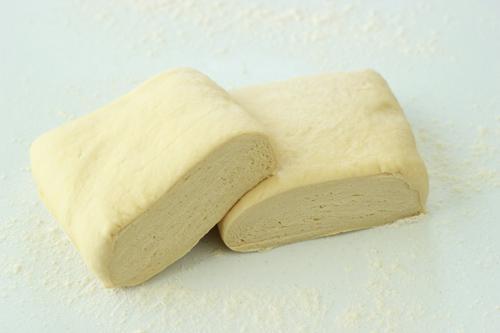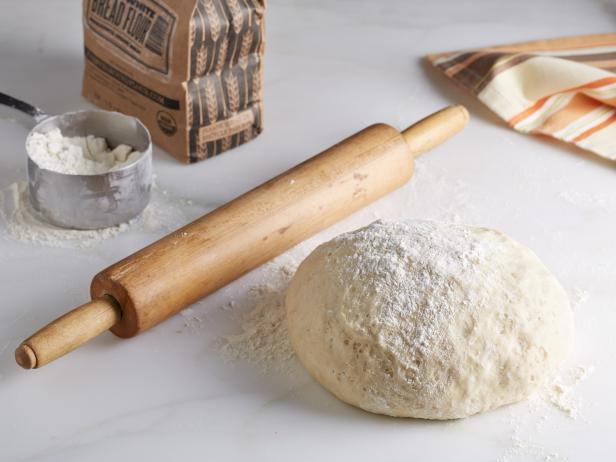The first image is the image on the left, the second image is the image on the right. Given the left and right images, does the statement "The dough has been flattened into a pizza crust shape in only one of the images." hold true? Answer yes or no. No. The first image is the image on the left, the second image is the image on the right. Examine the images to the left and right. Is the description "In one image a ball of dough is resting on a flour-dusted surface, while a second image shows dough flattened into a round disk." accurate? Answer yes or no. No. 